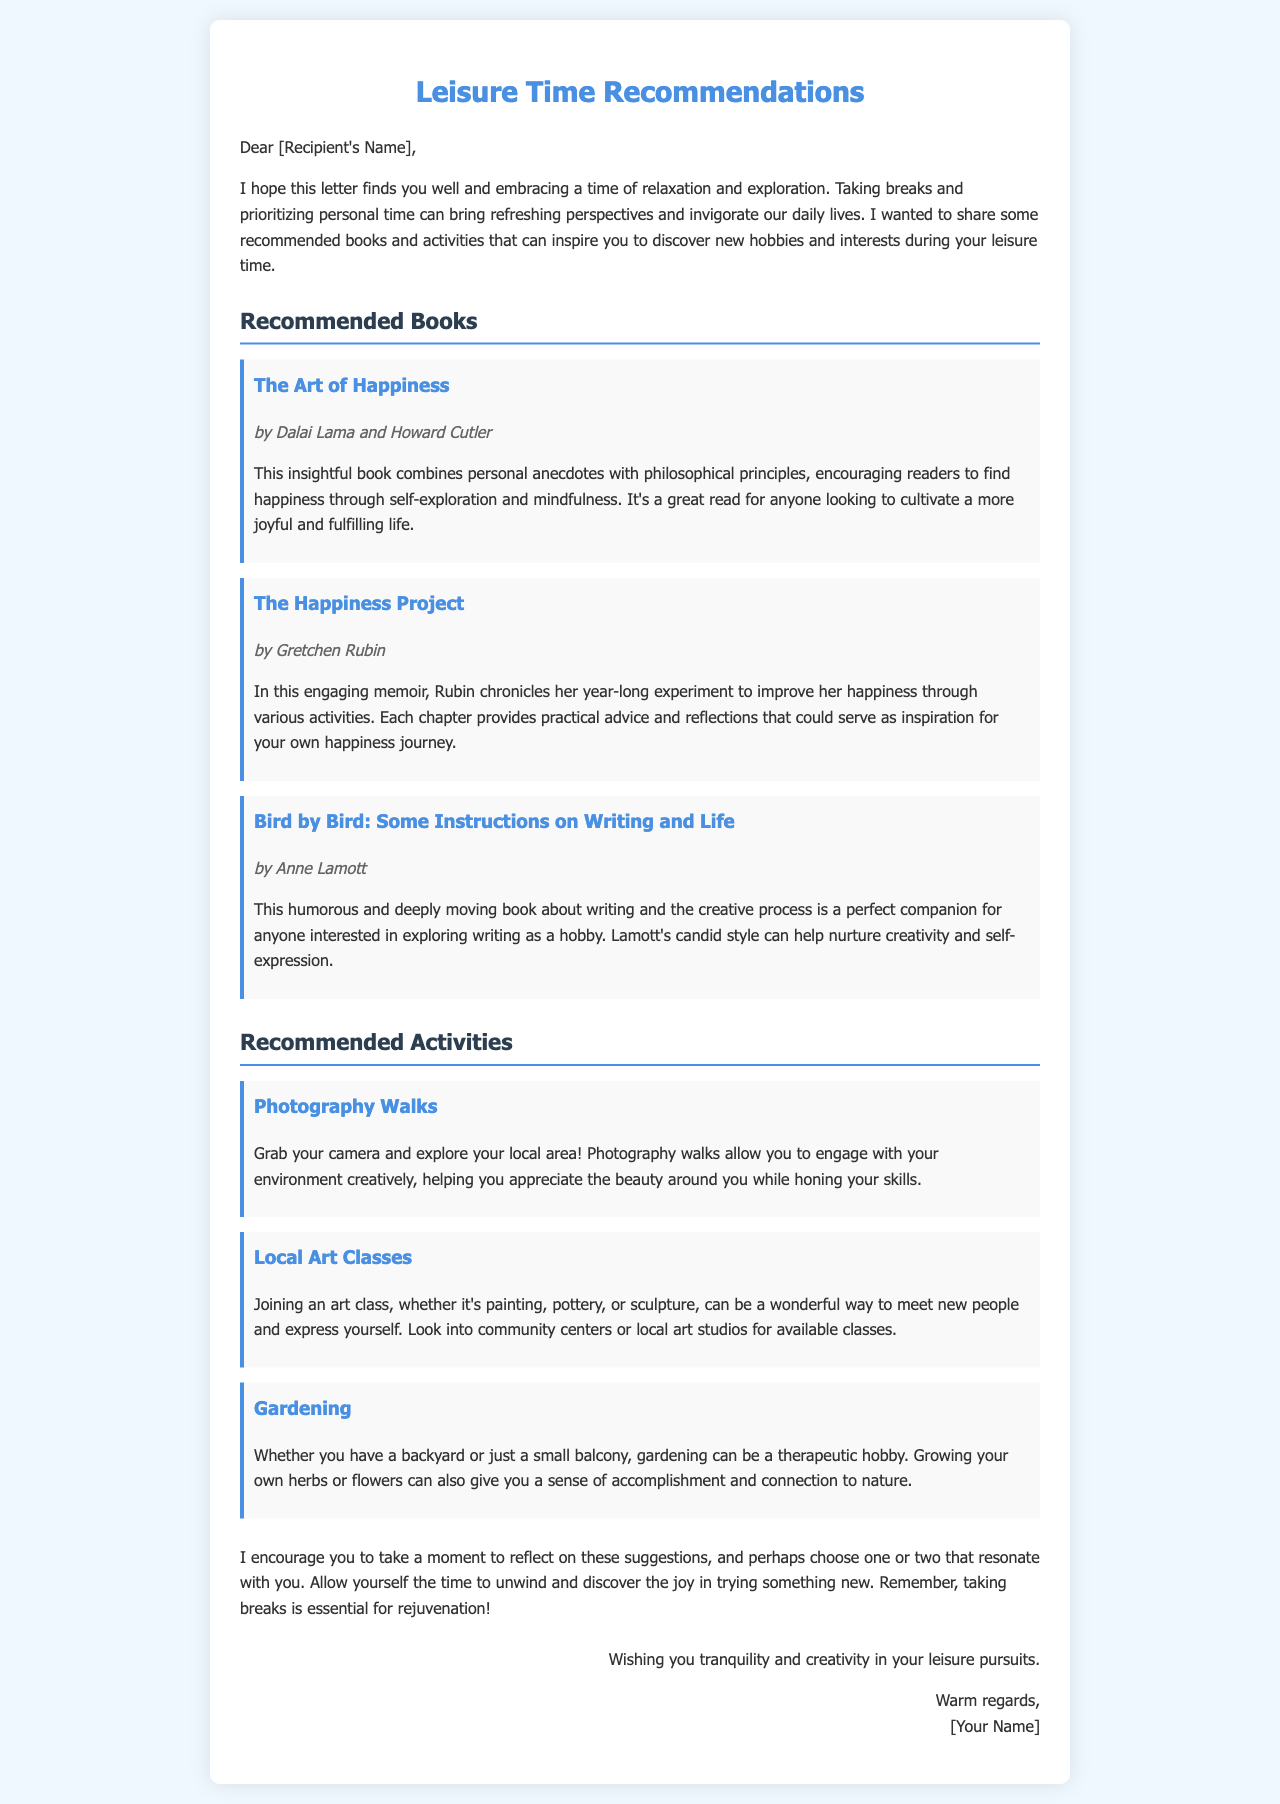what is the title of the first recommended book? The title of the first recommended book is mentioned in the "Recommended Books" section.
Answer: The Art of Happiness who are the authors of "The Happiness Project"? The authors of "The Happiness Project" are listed in the book details.
Answer: Gretchen Rubin what activity involves using a camera? This activity is described under the "Recommended Activities" section.
Answer: Photography Walks how many recommended books are there in the document? The number of recommended books can be counted from the "Recommended Books" section.
Answer: Three what is the theme of "Bird by Bird"? The theme is inferred from the description provided about the book.
Answer: Writing and life which hobby involves planting and nurturing plants? The specific hobby is mentioned in the "Recommended Activities" section.
Answer: Gardening what is the main focus of the letter? The main focus of the letter is described in the opening paragraphs.
Answer: Leisure time recommendations how does the letter encourage personal time? The encouragement is indicated through specific phrases and advice in the letter.
Answer: By sharing suggestions for relaxation and exploration 